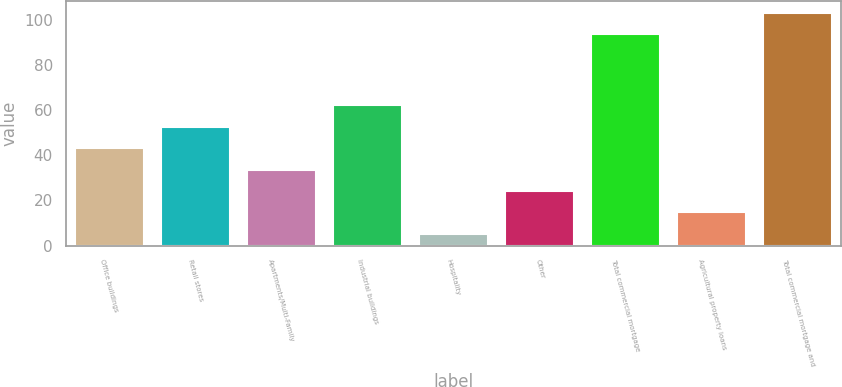Convert chart. <chart><loc_0><loc_0><loc_500><loc_500><bar_chart><fcel>Office buildings<fcel>Retail stores<fcel>Apartments/Multi-Family<fcel>Industrial buildings<fcel>Hospitality<fcel>Other<fcel>Total commercial mortgage<fcel>Agricultural property loans<fcel>Total commercial mortgage and<nl><fcel>43.18<fcel>52.65<fcel>33.71<fcel>62.12<fcel>5.3<fcel>24.24<fcel>93.7<fcel>14.77<fcel>103.17<nl></chart> 